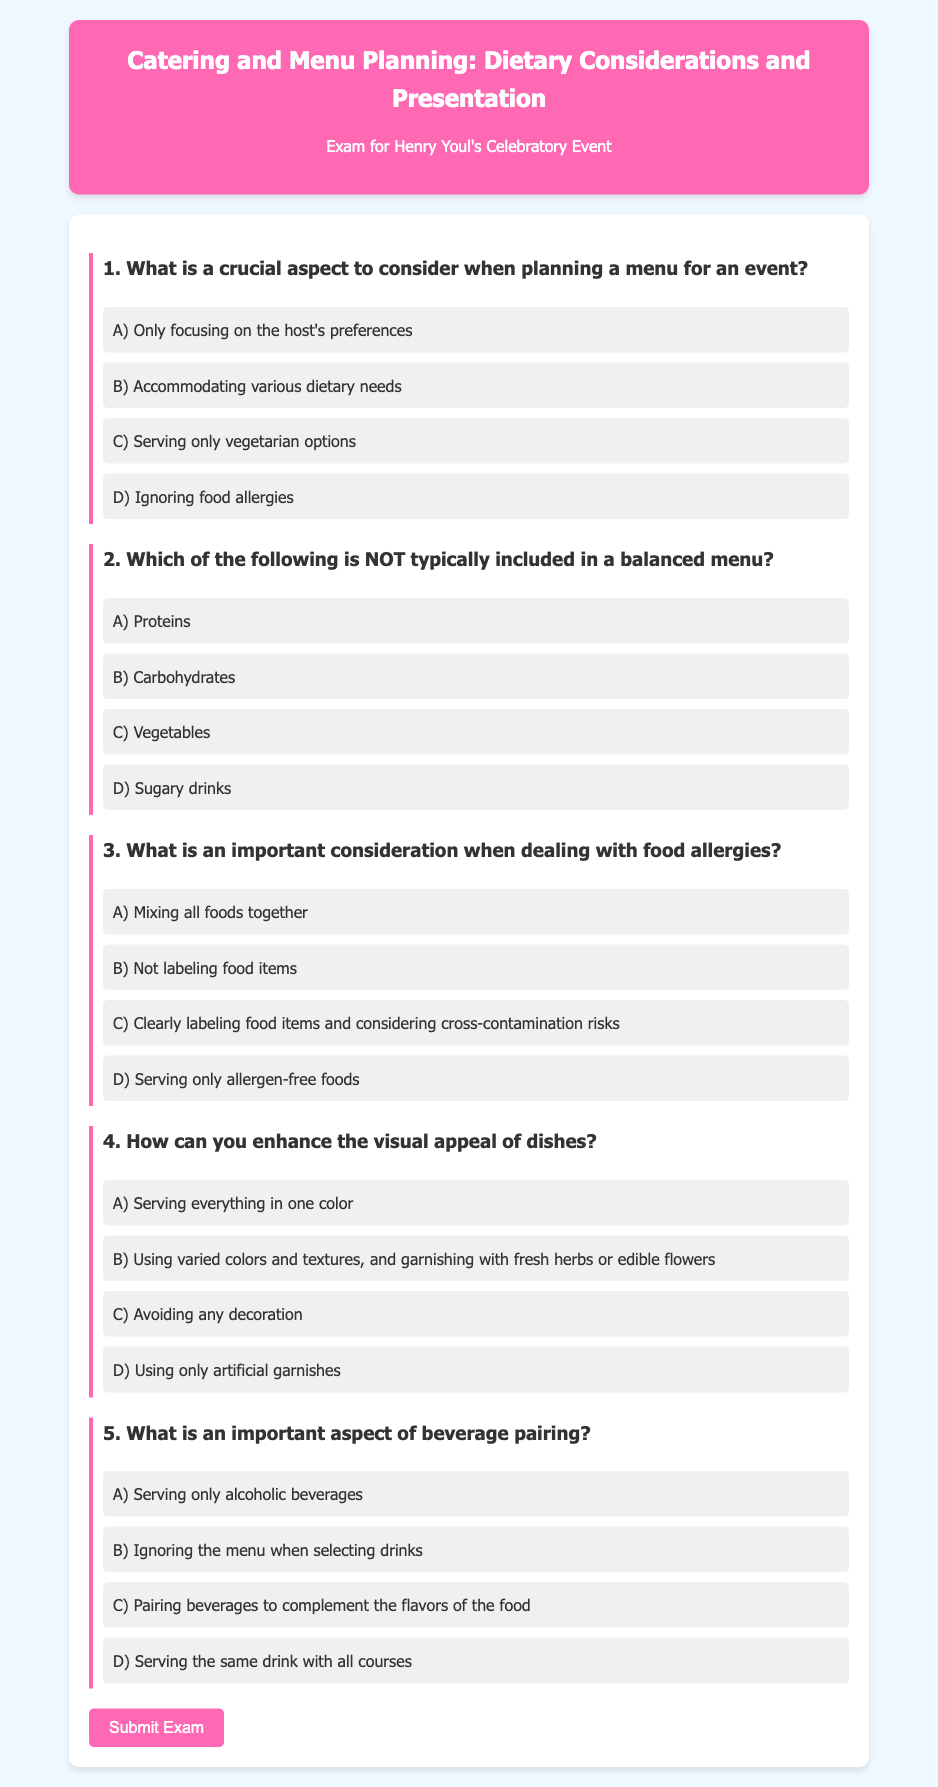What is the title of the exam? The title of the exam is presented in the header section of the document.
Answer: Catering and Menu Planning: Dietary Considerations and Presentation Who is the exam for? The document explicitly states the exam is for a specific individual, which is mentioned just below the title.
Answer: Henry Youl How many questions are included in the exam? The exam contains a set of questions, specifically outlined in the content, which must be counted manually.
Answer: 5 What color is used for the header background? The header background color is defined in the style section and is visually identifiable in the rendered document.
Answer: #ff69b4 What is the focus of the third question? The question discusses a specific topic related to food safety, particularly in terms of allergies, as indicated in the question text.
Answer: Food allergies What is one of the options for enhancing visual appeal of dishes? The document provides multiple choices, highlighting one as a recommended practice for presentation.
Answer: Using varied colors and textures What is an important aspect of beverage pairing according to the exam? One of the options in the fifth question points to a key principle in beverage selection for meals.
Answer: Complement the flavors of the food Which option is NOT included in a balanced menu? The second question explicitly asks which item does not fit in a balanced menu, and the answer can be found among the provided choices.
Answer: Sugary drinks What is the action button labeled in the document? The button at the bottom of the document serves a specific function and is labeled clearly.
Answer: Submit Exam 